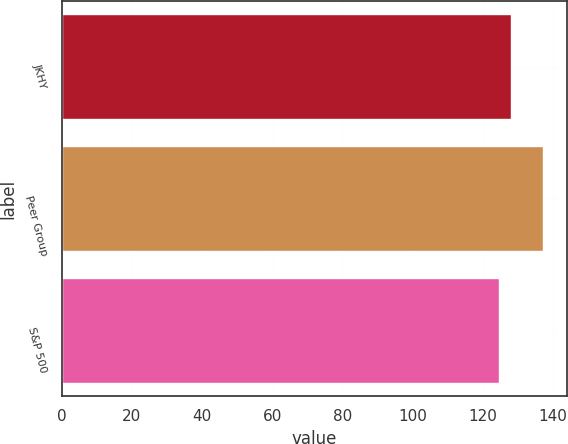<chart> <loc_0><loc_0><loc_500><loc_500><bar_chart><fcel>JKHY<fcel>Peer Group<fcel>S&P 500<nl><fcel>128.02<fcel>137.07<fcel>124.61<nl></chart> 